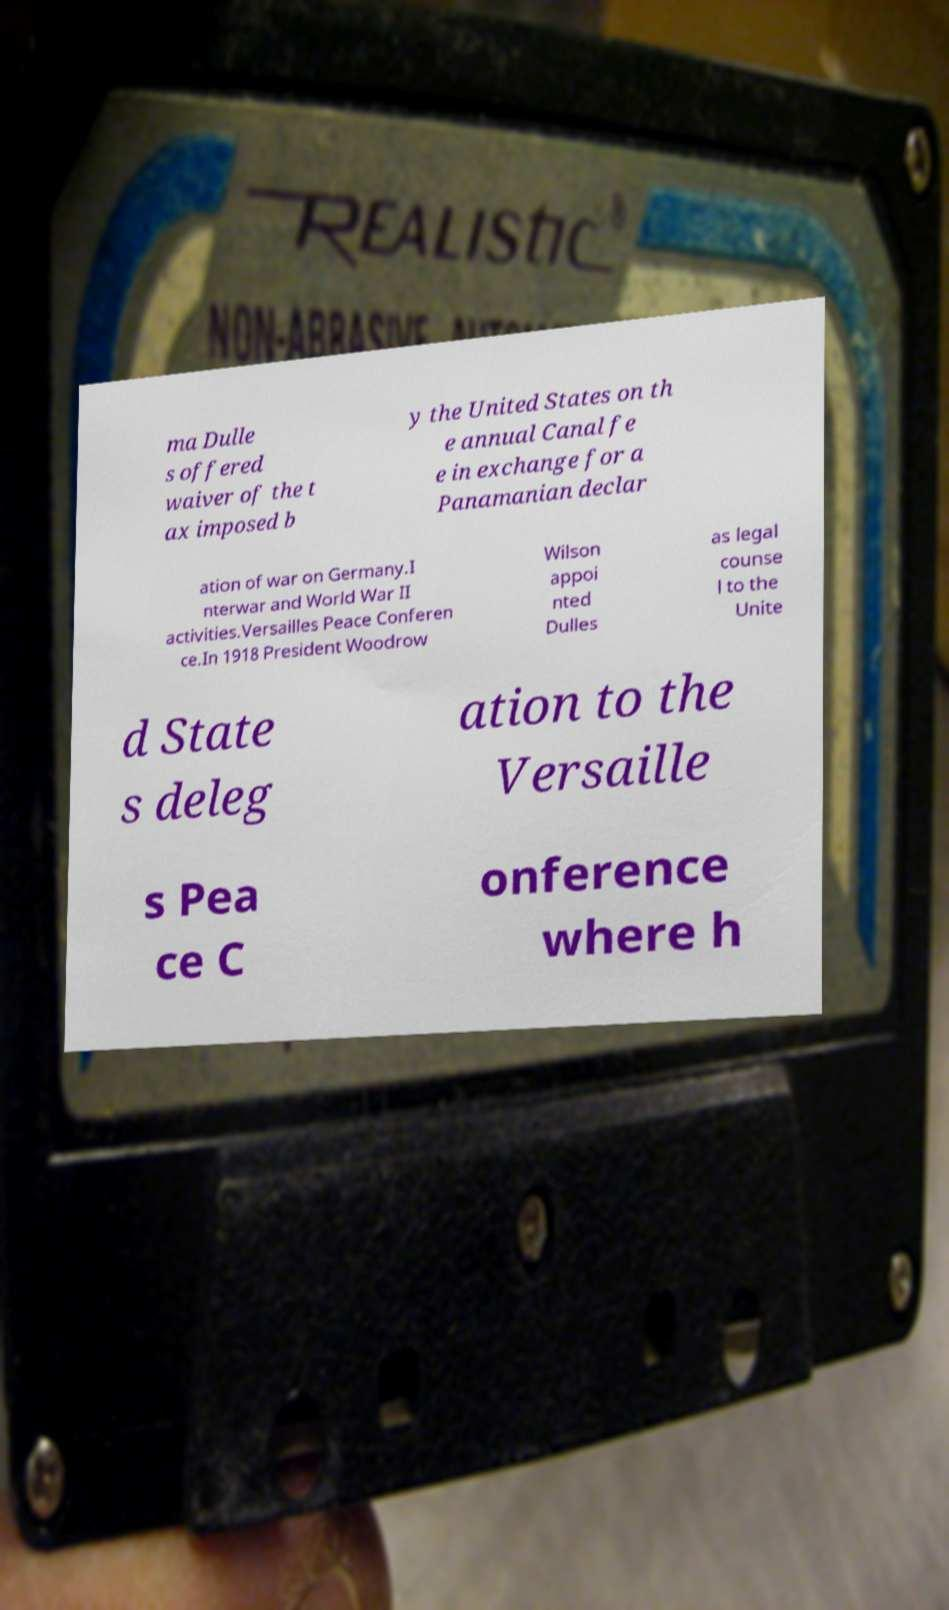Can you accurately transcribe the text from the provided image for me? ma Dulle s offered waiver of the t ax imposed b y the United States on th e annual Canal fe e in exchange for a Panamanian declar ation of war on Germany.I nterwar and World War II activities.Versailles Peace Conferen ce.In 1918 President Woodrow Wilson appoi nted Dulles as legal counse l to the Unite d State s deleg ation to the Versaille s Pea ce C onference where h 